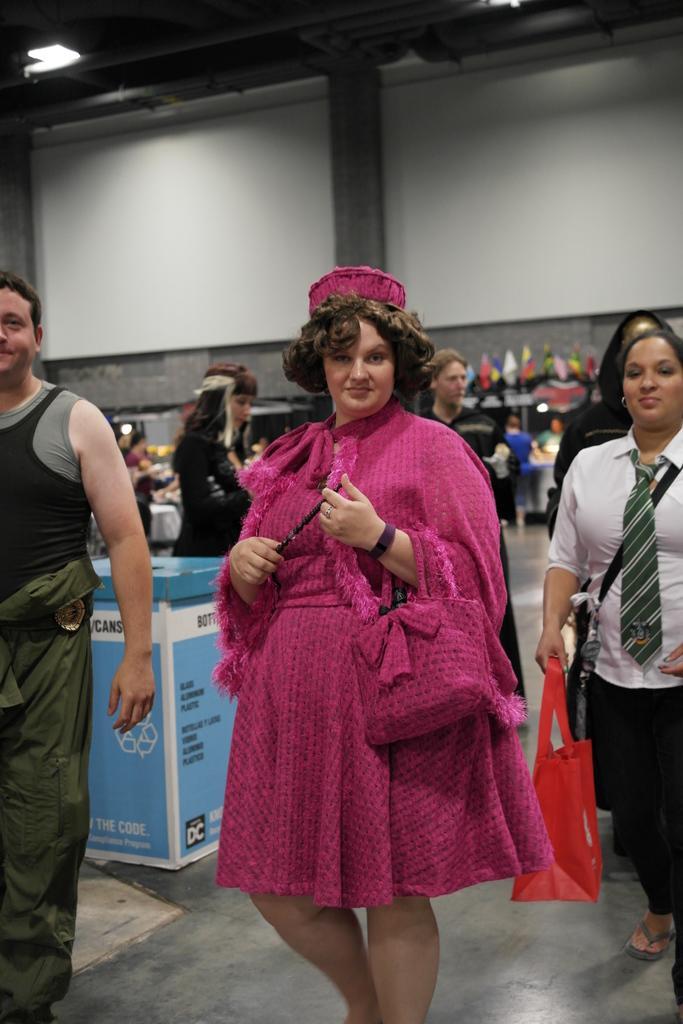Please provide a concise description of this image. In this image I can see number of people are standing. Here I can see she is wearing pink dress and pink cap. I can also see one of them is carrying a red colour bag. In the background I can see a blue colour thing and on it I can see something is written. I can also see this image is little bit blurry from background. 